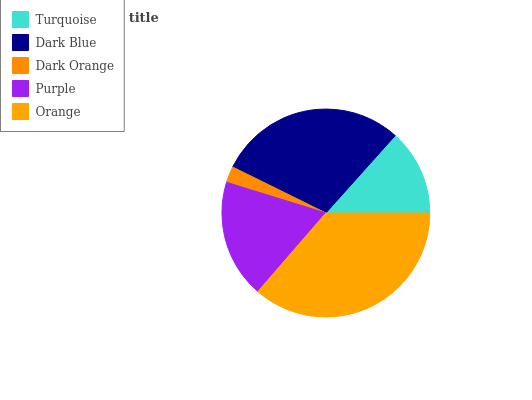Is Dark Orange the minimum?
Answer yes or no. Yes. Is Orange the maximum?
Answer yes or no. Yes. Is Dark Blue the minimum?
Answer yes or no. No. Is Dark Blue the maximum?
Answer yes or no. No. Is Dark Blue greater than Turquoise?
Answer yes or no. Yes. Is Turquoise less than Dark Blue?
Answer yes or no. Yes. Is Turquoise greater than Dark Blue?
Answer yes or no. No. Is Dark Blue less than Turquoise?
Answer yes or no. No. Is Purple the high median?
Answer yes or no. Yes. Is Purple the low median?
Answer yes or no. Yes. Is Turquoise the high median?
Answer yes or no. No. Is Orange the low median?
Answer yes or no. No. 